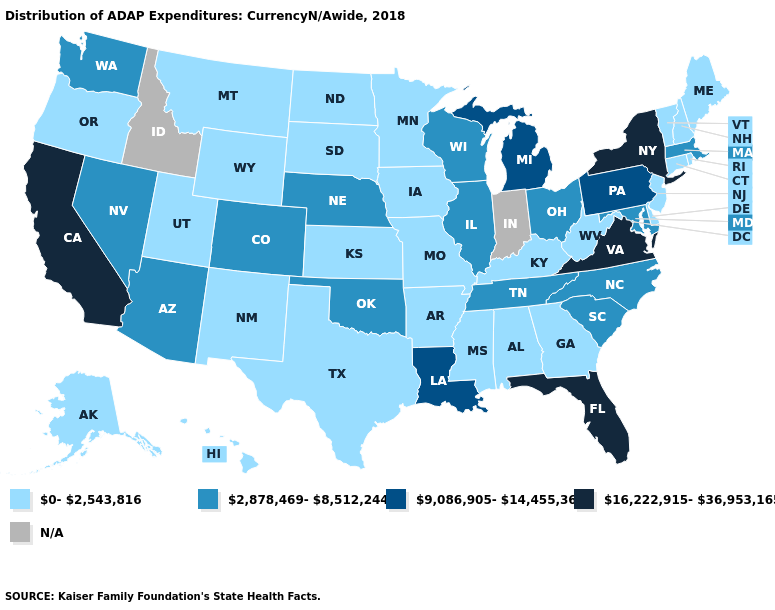Does California have the highest value in the USA?
Give a very brief answer. Yes. Does the map have missing data?
Answer briefly. Yes. Which states have the lowest value in the USA?
Answer briefly. Alabama, Alaska, Arkansas, Connecticut, Delaware, Georgia, Hawaii, Iowa, Kansas, Kentucky, Maine, Minnesota, Mississippi, Missouri, Montana, New Hampshire, New Jersey, New Mexico, North Dakota, Oregon, Rhode Island, South Dakota, Texas, Utah, Vermont, West Virginia, Wyoming. What is the value of Massachusetts?
Keep it brief. 2,878,469-8,512,244. What is the value of Delaware?
Give a very brief answer. 0-2,543,816. Among the states that border Massachusetts , which have the highest value?
Concise answer only. New York. What is the highest value in the West ?
Concise answer only. 16,222,915-36,953,165. Name the states that have a value in the range 16,222,915-36,953,165?
Quick response, please. California, Florida, New York, Virginia. Does Ohio have the highest value in the USA?
Answer briefly. No. Which states have the highest value in the USA?
Concise answer only. California, Florida, New York, Virginia. Name the states that have a value in the range 9,086,905-14,455,361?
Answer briefly. Louisiana, Michigan, Pennsylvania. What is the value of Pennsylvania?
Short answer required. 9,086,905-14,455,361. Name the states that have a value in the range 2,878,469-8,512,244?
Be succinct. Arizona, Colorado, Illinois, Maryland, Massachusetts, Nebraska, Nevada, North Carolina, Ohio, Oklahoma, South Carolina, Tennessee, Washington, Wisconsin. What is the value of Hawaii?
Quick response, please. 0-2,543,816. What is the highest value in the Northeast ?
Short answer required. 16,222,915-36,953,165. 